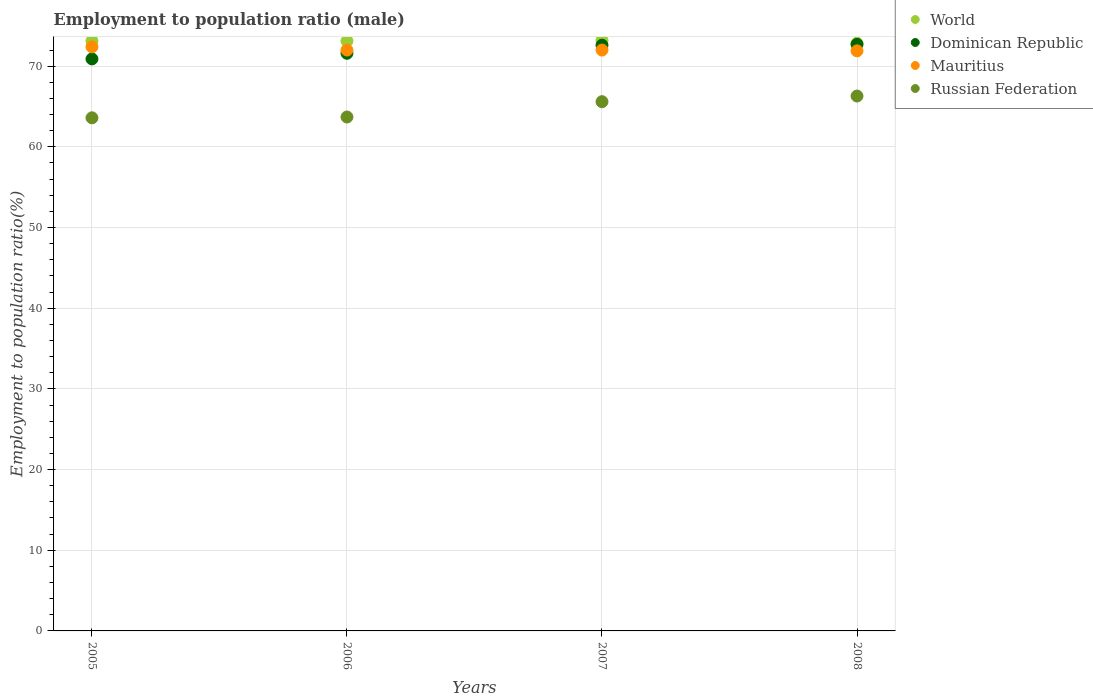What is the employment to population ratio in Russian Federation in 2008?
Your response must be concise. 66.3. Across all years, what is the maximum employment to population ratio in Mauritius?
Make the answer very short. 72.4. Across all years, what is the minimum employment to population ratio in Russian Federation?
Offer a terse response. 63.6. In which year was the employment to population ratio in Mauritius minimum?
Give a very brief answer. 2008. What is the total employment to population ratio in Mauritius in the graph?
Keep it short and to the point. 288.3. What is the difference between the employment to population ratio in Mauritius in 2005 and that in 2006?
Offer a very short reply. 0.4. What is the difference between the employment to population ratio in Russian Federation in 2005 and the employment to population ratio in Dominican Republic in 2008?
Ensure brevity in your answer.  -9.1. What is the average employment to population ratio in World per year?
Keep it short and to the point. 73.07. In the year 2005, what is the difference between the employment to population ratio in World and employment to population ratio in Dominican Republic?
Make the answer very short. 2.24. In how many years, is the employment to population ratio in Russian Federation greater than 24 %?
Your response must be concise. 4. What is the ratio of the employment to population ratio in World in 2007 to that in 2008?
Offer a terse response. 1. Is the employment to population ratio in Mauritius in 2005 less than that in 2007?
Your response must be concise. No. What is the difference between the highest and the second highest employment to population ratio in Mauritius?
Ensure brevity in your answer.  0.4. What is the difference between the highest and the lowest employment to population ratio in World?
Make the answer very short. 0.34. Is it the case that in every year, the sum of the employment to population ratio in World and employment to population ratio in Dominican Republic  is greater than the employment to population ratio in Mauritius?
Provide a succinct answer. Yes. Is the employment to population ratio in Mauritius strictly greater than the employment to population ratio in World over the years?
Make the answer very short. No. Is the employment to population ratio in Dominican Republic strictly less than the employment to population ratio in Mauritius over the years?
Offer a very short reply. No. How many dotlines are there?
Give a very brief answer. 4. Are the values on the major ticks of Y-axis written in scientific E-notation?
Provide a succinct answer. No. Where does the legend appear in the graph?
Your answer should be compact. Top right. How many legend labels are there?
Provide a succinct answer. 4. How are the legend labels stacked?
Give a very brief answer. Vertical. What is the title of the graph?
Offer a very short reply. Employment to population ratio (male). Does "Tunisia" appear as one of the legend labels in the graph?
Your response must be concise. No. What is the label or title of the X-axis?
Offer a very short reply. Years. What is the Employment to population ratio(%) of World in 2005?
Give a very brief answer. 73.14. What is the Employment to population ratio(%) in Dominican Republic in 2005?
Your answer should be compact. 70.9. What is the Employment to population ratio(%) in Mauritius in 2005?
Give a very brief answer. 72.4. What is the Employment to population ratio(%) in Russian Federation in 2005?
Provide a succinct answer. 63.6. What is the Employment to population ratio(%) in World in 2006?
Your response must be concise. 73.12. What is the Employment to population ratio(%) of Dominican Republic in 2006?
Ensure brevity in your answer.  71.6. What is the Employment to population ratio(%) of Russian Federation in 2006?
Provide a succinct answer. 63.7. What is the Employment to population ratio(%) in World in 2007?
Give a very brief answer. 73.19. What is the Employment to population ratio(%) of Dominican Republic in 2007?
Offer a very short reply. 72.6. What is the Employment to population ratio(%) in Mauritius in 2007?
Give a very brief answer. 72. What is the Employment to population ratio(%) of Russian Federation in 2007?
Provide a succinct answer. 65.6. What is the Employment to population ratio(%) in World in 2008?
Your answer should be compact. 72.85. What is the Employment to population ratio(%) of Dominican Republic in 2008?
Your response must be concise. 72.7. What is the Employment to population ratio(%) in Mauritius in 2008?
Your response must be concise. 71.9. What is the Employment to population ratio(%) in Russian Federation in 2008?
Provide a short and direct response. 66.3. Across all years, what is the maximum Employment to population ratio(%) of World?
Provide a short and direct response. 73.19. Across all years, what is the maximum Employment to population ratio(%) in Dominican Republic?
Offer a very short reply. 72.7. Across all years, what is the maximum Employment to population ratio(%) of Mauritius?
Your response must be concise. 72.4. Across all years, what is the maximum Employment to population ratio(%) of Russian Federation?
Ensure brevity in your answer.  66.3. Across all years, what is the minimum Employment to population ratio(%) of World?
Ensure brevity in your answer.  72.85. Across all years, what is the minimum Employment to population ratio(%) of Dominican Republic?
Your answer should be compact. 70.9. Across all years, what is the minimum Employment to population ratio(%) in Mauritius?
Give a very brief answer. 71.9. Across all years, what is the minimum Employment to population ratio(%) in Russian Federation?
Ensure brevity in your answer.  63.6. What is the total Employment to population ratio(%) in World in the graph?
Offer a terse response. 292.3. What is the total Employment to population ratio(%) of Dominican Republic in the graph?
Ensure brevity in your answer.  287.8. What is the total Employment to population ratio(%) of Mauritius in the graph?
Make the answer very short. 288.3. What is the total Employment to population ratio(%) of Russian Federation in the graph?
Keep it short and to the point. 259.2. What is the difference between the Employment to population ratio(%) of World in 2005 and that in 2006?
Keep it short and to the point. 0.02. What is the difference between the Employment to population ratio(%) in World in 2005 and that in 2007?
Make the answer very short. -0.05. What is the difference between the Employment to population ratio(%) of Russian Federation in 2005 and that in 2007?
Your answer should be very brief. -2. What is the difference between the Employment to population ratio(%) of World in 2005 and that in 2008?
Your answer should be compact. 0.29. What is the difference between the Employment to population ratio(%) of Russian Federation in 2005 and that in 2008?
Ensure brevity in your answer.  -2.7. What is the difference between the Employment to population ratio(%) in World in 2006 and that in 2007?
Your response must be concise. -0.07. What is the difference between the Employment to population ratio(%) in Dominican Republic in 2006 and that in 2007?
Your response must be concise. -1. What is the difference between the Employment to population ratio(%) in World in 2006 and that in 2008?
Make the answer very short. 0.27. What is the difference between the Employment to population ratio(%) in Russian Federation in 2006 and that in 2008?
Make the answer very short. -2.6. What is the difference between the Employment to population ratio(%) in World in 2007 and that in 2008?
Provide a short and direct response. 0.34. What is the difference between the Employment to population ratio(%) of Dominican Republic in 2007 and that in 2008?
Your answer should be very brief. -0.1. What is the difference between the Employment to population ratio(%) of Mauritius in 2007 and that in 2008?
Give a very brief answer. 0.1. What is the difference between the Employment to population ratio(%) in Russian Federation in 2007 and that in 2008?
Offer a very short reply. -0.7. What is the difference between the Employment to population ratio(%) in World in 2005 and the Employment to population ratio(%) in Dominican Republic in 2006?
Ensure brevity in your answer.  1.54. What is the difference between the Employment to population ratio(%) in World in 2005 and the Employment to population ratio(%) in Mauritius in 2006?
Provide a short and direct response. 1.14. What is the difference between the Employment to population ratio(%) of World in 2005 and the Employment to population ratio(%) of Russian Federation in 2006?
Your answer should be compact. 9.44. What is the difference between the Employment to population ratio(%) of Dominican Republic in 2005 and the Employment to population ratio(%) of Mauritius in 2006?
Ensure brevity in your answer.  -1.1. What is the difference between the Employment to population ratio(%) of Dominican Republic in 2005 and the Employment to population ratio(%) of Russian Federation in 2006?
Keep it short and to the point. 7.2. What is the difference between the Employment to population ratio(%) of Mauritius in 2005 and the Employment to population ratio(%) of Russian Federation in 2006?
Offer a very short reply. 8.7. What is the difference between the Employment to population ratio(%) in World in 2005 and the Employment to population ratio(%) in Dominican Republic in 2007?
Make the answer very short. 0.54. What is the difference between the Employment to population ratio(%) of World in 2005 and the Employment to population ratio(%) of Mauritius in 2007?
Your answer should be very brief. 1.14. What is the difference between the Employment to population ratio(%) in World in 2005 and the Employment to population ratio(%) in Russian Federation in 2007?
Your answer should be compact. 7.54. What is the difference between the Employment to population ratio(%) in Dominican Republic in 2005 and the Employment to population ratio(%) in Mauritius in 2007?
Ensure brevity in your answer.  -1.1. What is the difference between the Employment to population ratio(%) in Mauritius in 2005 and the Employment to population ratio(%) in Russian Federation in 2007?
Your response must be concise. 6.8. What is the difference between the Employment to population ratio(%) in World in 2005 and the Employment to population ratio(%) in Dominican Republic in 2008?
Keep it short and to the point. 0.44. What is the difference between the Employment to population ratio(%) in World in 2005 and the Employment to population ratio(%) in Mauritius in 2008?
Ensure brevity in your answer.  1.24. What is the difference between the Employment to population ratio(%) in World in 2005 and the Employment to population ratio(%) in Russian Federation in 2008?
Offer a terse response. 6.84. What is the difference between the Employment to population ratio(%) in Dominican Republic in 2005 and the Employment to population ratio(%) in Russian Federation in 2008?
Provide a short and direct response. 4.6. What is the difference between the Employment to population ratio(%) of World in 2006 and the Employment to population ratio(%) of Dominican Republic in 2007?
Make the answer very short. 0.52. What is the difference between the Employment to population ratio(%) in World in 2006 and the Employment to population ratio(%) in Mauritius in 2007?
Keep it short and to the point. 1.12. What is the difference between the Employment to population ratio(%) of World in 2006 and the Employment to population ratio(%) of Russian Federation in 2007?
Keep it short and to the point. 7.52. What is the difference between the Employment to population ratio(%) of Dominican Republic in 2006 and the Employment to population ratio(%) of Russian Federation in 2007?
Ensure brevity in your answer.  6. What is the difference between the Employment to population ratio(%) in World in 2006 and the Employment to population ratio(%) in Dominican Republic in 2008?
Offer a terse response. 0.42. What is the difference between the Employment to population ratio(%) of World in 2006 and the Employment to population ratio(%) of Mauritius in 2008?
Keep it short and to the point. 1.22. What is the difference between the Employment to population ratio(%) in World in 2006 and the Employment to population ratio(%) in Russian Federation in 2008?
Your answer should be very brief. 6.82. What is the difference between the Employment to population ratio(%) of Dominican Republic in 2006 and the Employment to population ratio(%) of Russian Federation in 2008?
Make the answer very short. 5.3. What is the difference between the Employment to population ratio(%) in Mauritius in 2006 and the Employment to population ratio(%) in Russian Federation in 2008?
Your answer should be compact. 5.7. What is the difference between the Employment to population ratio(%) of World in 2007 and the Employment to population ratio(%) of Dominican Republic in 2008?
Offer a very short reply. 0.49. What is the difference between the Employment to population ratio(%) of World in 2007 and the Employment to population ratio(%) of Mauritius in 2008?
Keep it short and to the point. 1.29. What is the difference between the Employment to population ratio(%) of World in 2007 and the Employment to population ratio(%) of Russian Federation in 2008?
Offer a very short reply. 6.89. What is the average Employment to population ratio(%) in World per year?
Offer a terse response. 73.07. What is the average Employment to population ratio(%) of Dominican Republic per year?
Your answer should be very brief. 71.95. What is the average Employment to population ratio(%) in Mauritius per year?
Ensure brevity in your answer.  72.08. What is the average Employment to population ratio(%) of Russian Federation per year?
Your answer should be very brief. 64.8. In the year 2005, what is the difference between the Employment to population ratio(%) of World and Employment to population ratio(%) of Dominican Republic?
Ensure brevity in your answer.  2.24. In the year 2005, what is the difference between the Employment to population ratio(%) in World and Employment to population ratio(%) in Mauritius?
Provide a short and direct response. 0.74. In the year 2005, what is the difference between the Employment to population ratio(%) of World and Employment to population ratio(%) of Russian Federation?
Your response must be concise. 9.54. In the year 2005, what is the difference between the Employment to population ratio(%) of Dominican Republic and Employment to population ratio(%) of Mauritius?
Make the answer very short. -1.5. In the year 2005, what is the difference between the Employment to population ratio(%) of Mauritius and Employment to population ratio(%) of Russian Federation?
Your response must be concise. 8.8. In the year 2006, what is the difference between the Employment to population ratio(%) in World and Employment to population ratio(%) in Dominican Republic?
Offer a terse response. 1.52. In the year 2006, what is the difference between the Employment to population ratio(%) of World and Employment to population ratio(%) of Mauritius?
Your response must be concise. 1.12. In the year 2006, what is the difference between the Employment to population ratio(%) of World and Employment to population ratio(%) of Russian Federation?
Your answer should be very brief. 9.42. In the year 2006, what is the difference between the Employment to population ratio(%) of Dominican Republic and Employment to population ratio(%) of Mauritius?
Your answer should be very brief. -0.4. In the year 2006, what is the difference between the Employment to population ratio(%) of Dominican Republic and Employment to population ratio(%) of Russian Federation?
Provide a short and direct response. 7.9. In the year 2007, what is the difference between the Employment to population ratio(%) in World and Employment to population ratio(%) in Dominican Republic?
Provide a succinct answer. 0.59. In the year 2007, what is the difference between the Employment to population ratio(%) in World and Employment to population ratio(%) in Mauritius?
Give a very brief answer. 1.19. In the year 2007, what is the difference between the Employment to population ratio(%) in World and Employment to population ratio(%) in Russian Federation?
Provide a succinct answer. 7.59. In the year 2008, what is the difference between the Employment to population ratio(%) of World and Employment to population ratio(%) of Dominican Republic?
Offer a very short reply. 0.15. In the year 2008, what is the difference between the Employment to population ratio(%) of World and Employment to population ratio(%) of Russian Federation?
Provide a short and direct response. 6.55. In the year 2008, what is the difference between the Employment to population ratio(%) in Dominican Republic and Employment to population ratio(%) in Mauritius?
Your response must be concise. 0.8. What is the ratio of the Employment to population ratio(%) in Dominican Republic in 2005 to that in 2006?
Your answer should be very brief. 0.99. What is the ratio of the Employment to population ratio(%) in Mauritius in 2005 to that in 2006?
Your answer should be compact. 1.01. What is the ratio of the Employment to population ratio(%) of Russian Federation in 2005 to that in 2006?
Give a very brief answer. 1. What is the ratio of the Employment to population ratio(%) of World in 2005 to that in 2007?
Your response must be concise. 1. What is the ratio of the Employment to population ratio(%) in Dominican Republic in 2005 to that in 2007?
Your response must be concise. 0.98. What is the ratio of the Employment to population ratio(%) of Mauritius in 2005 to that in 2007?
Provide a short and direct response. 1.01. What is the ratio of the Employment to population ratio(%) of Russian Federation in 2005 to that in 2007?
Keep it short and to the point. 0.97. What is the ratio of the Employment to population ratio(%) in Dominican Republic in 2005 to that in 2008?
Give a very brief answer. 0.98. What is the ratio of the Employment to population ratio(%) in Russian Federation in 2005 to that in 2008?
Your answer should be very brief. 0.96. What is the ratio of the Employment to population ratio(%) in Dominican Republic in 2006 to that in 2007?
Your answer should be very brief. 0.99. What is the ratio of the Employment to population ratio(%) of Dominican Republic in 2006 to that in 2008?
Give a very brief answer. 0.98. What is the ratio of the Employment to population ratio(%) in Mauritius in 2006 to that in 2008?
Your answer should be compact. 1. What is the ratio of the Employment to population ratio(%) of Russian Federation in 2006 to that in 2008?
Provide a short and direct response. 0.96. What is the ratio of the Employment to population ratio(%) in World in 2007 to that in 2008?
Provide a short and direct response. 1. What is the ratio of the Employment to population ratio(%) of Mauritius in 2007 to that in 2008?
Your response must be concise. 1. What is the difference between the highest and the second highest Employment to population ratio(%) in World?
Make the answer very short. 0.05. What is the difference between the highest and the second highest Employment to population ratio(%) in Mauritius?
Your answer should be compact. 0.4. What is the difference between the highest and the second highest Employment to population ratio(%) in Russian Federation?
Your answer should be compact. 0.7. What is the difference between the highest and the lowest Employment to population ratio(%) in World?
Provide a succinct answer. 0.34. What is the difference between the highest and the lowest Employment to population ratio(%) in Mauritius?
Make the answer very short. 0.5. What is the difference between the highest and the lowest Employment to population ratio(%) of Russian Federation?
Provide a short and direct response. 2.7. 